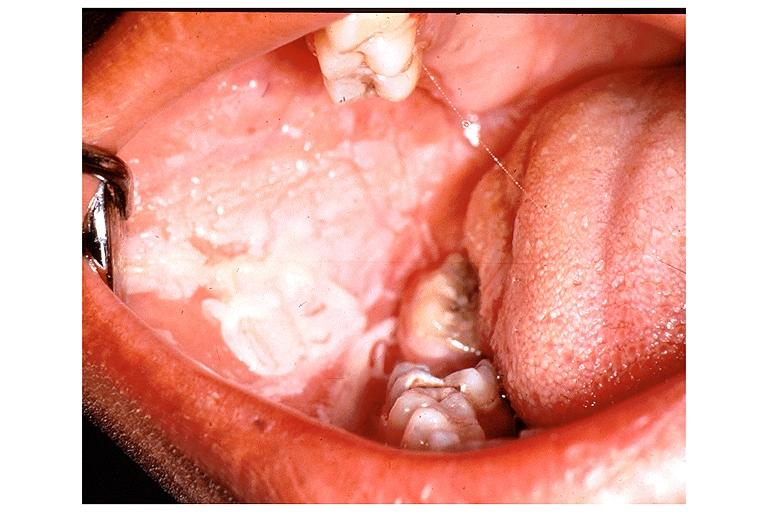what do chemical burn?
Answer the question using a single word or phrase. From topical asprin 